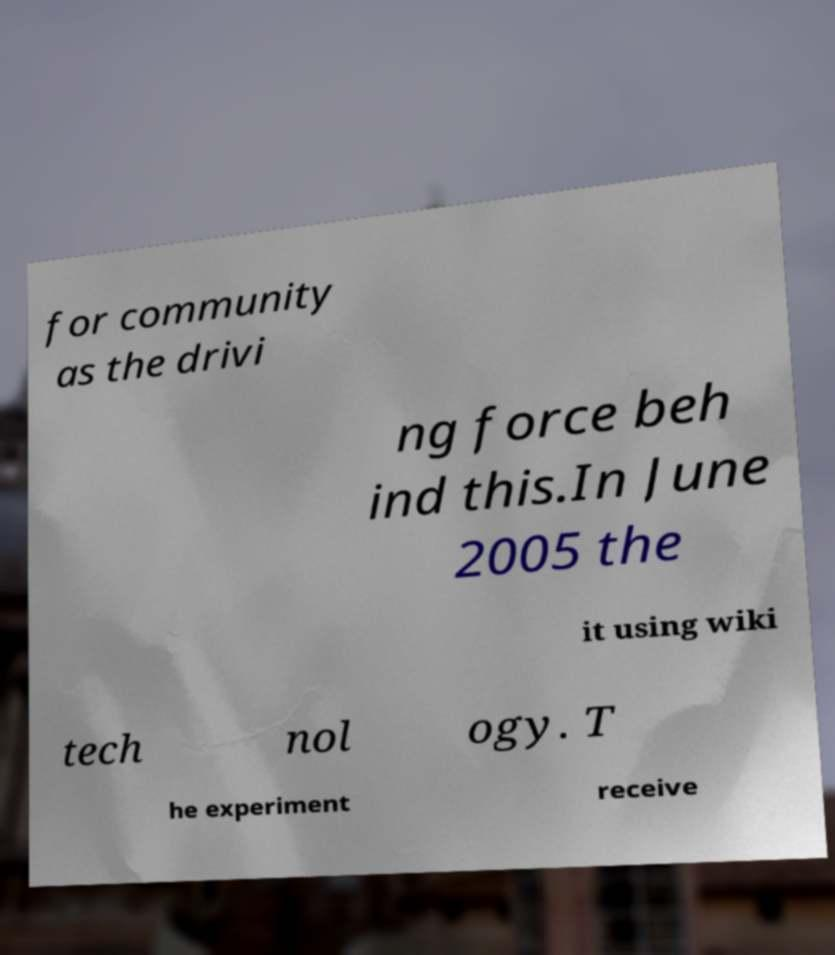For documentation purposes, I need the text within this image transcribed. Could you provide that? for community as the drivi ng force beh ind this.In June 2005 the it using wiki tech nol ogy. T he experiment receive 